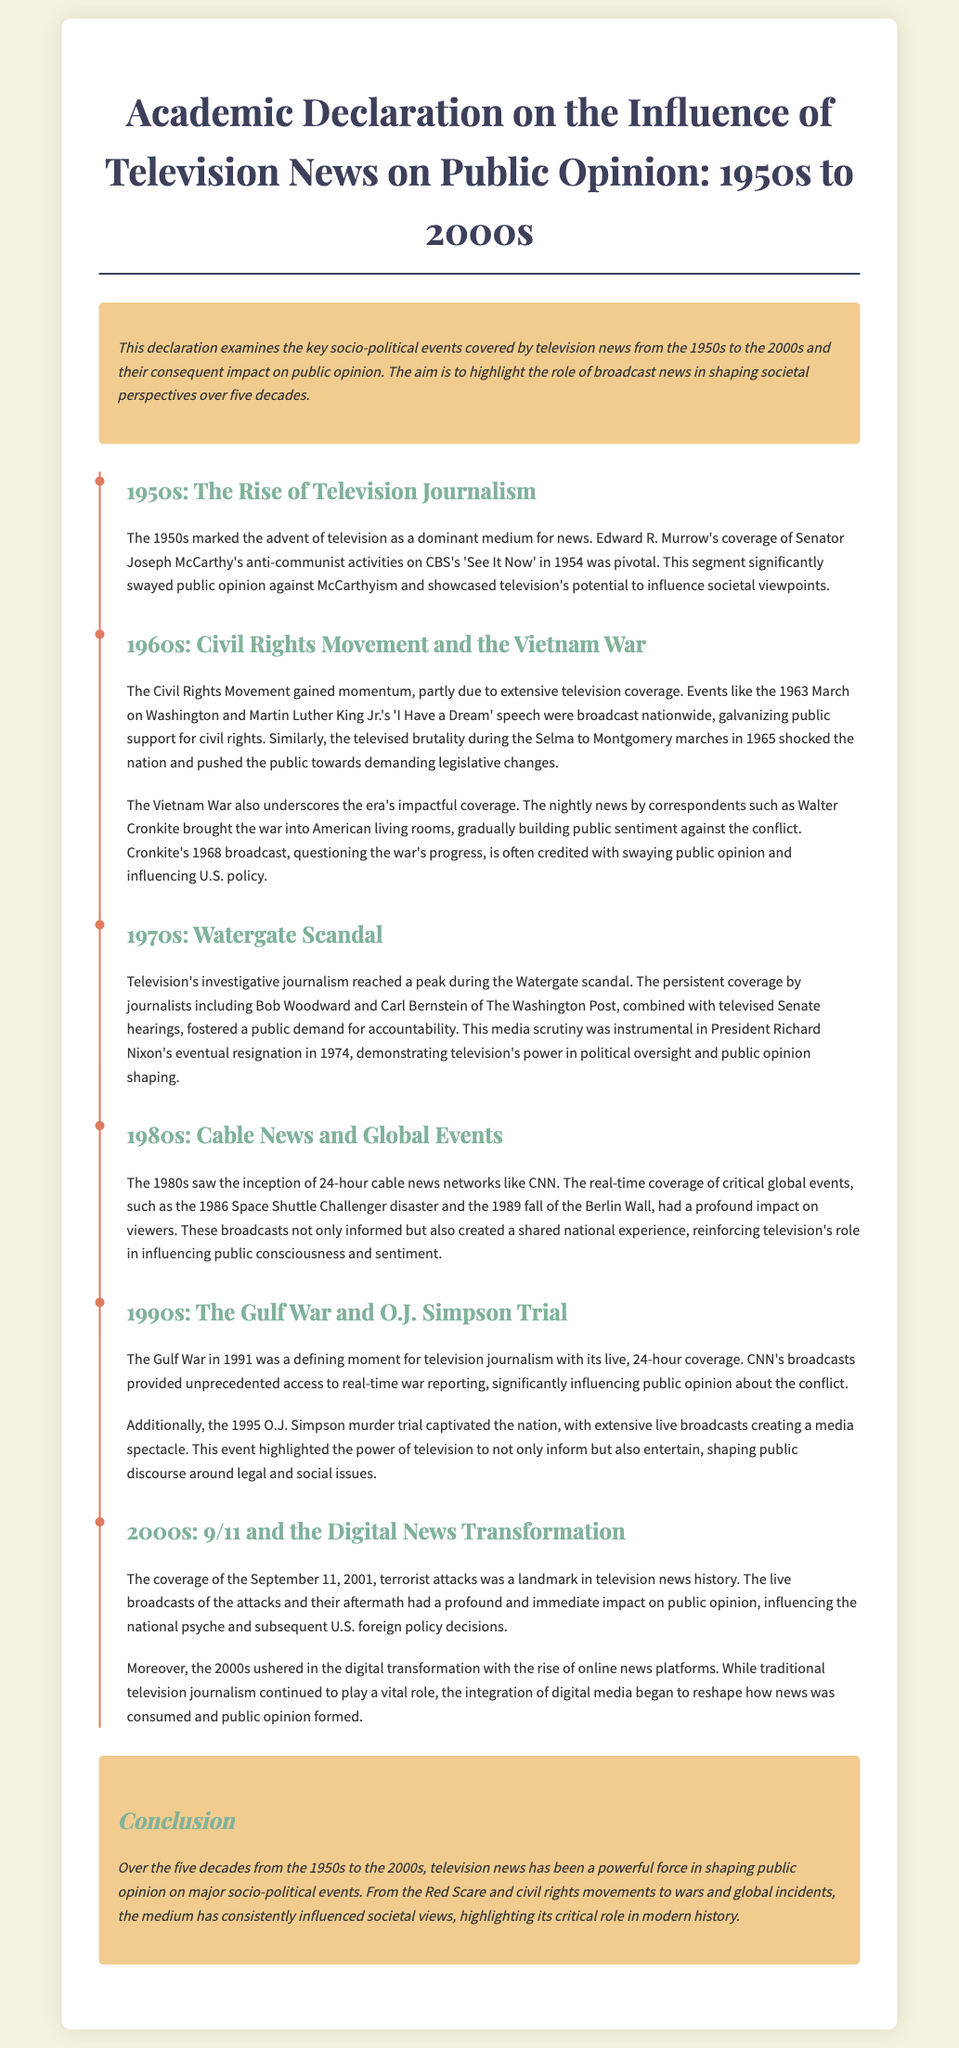What year did Edward R. Murrow cover McCarthy's activities? The document states that Edward R. Murrow's coverage occurred in 1954.
Answer: 1954 Which event in the 1960s significantly pushed public sentiment for civil rights? According to the document, the 1963 March on Washington and Martin Luther King Jr.'s speech were pivotal events.
Answer: March on Washington What political scandal is associated with the 1970s? The document mentions the Watergate scandal as a key event in the 1970s.
Answer: Watergate What type of media emerged in the 1980s? The document indicates that 24-hour cable news networks, like CNN, were established in the 1980s.
Answer: Cable news Which event marked a significant moment in the coverage of military conflict? The Gulf War is highlighted in the document as a defining moment for television journalism.
Answer: Gulf War How did television coverage impact public opinion after the September 11 attacks? The document notes that the live broadcasts had a profound impact on public opinion and national psyche.
Answer: Profound impact What significant change in news consumption began in the 2000s? The document describes the digital transformation with the rise of online news platforms as significant in the 2000s.
Answer: Digital transformation What is the overall theme of the declaration? The document concludes that television news has shaped public opinion on major socio-political events across decades.
Answer: Shaped public opinion 